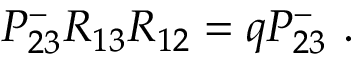<formula> <loc_0><loc_0><loc_500><loc_500>P _ { 2 3 } ^ { - } R _ { 1 3 } R _ { 1 2 } = q P _ { 2 3 } ^ { - } .</formula> 